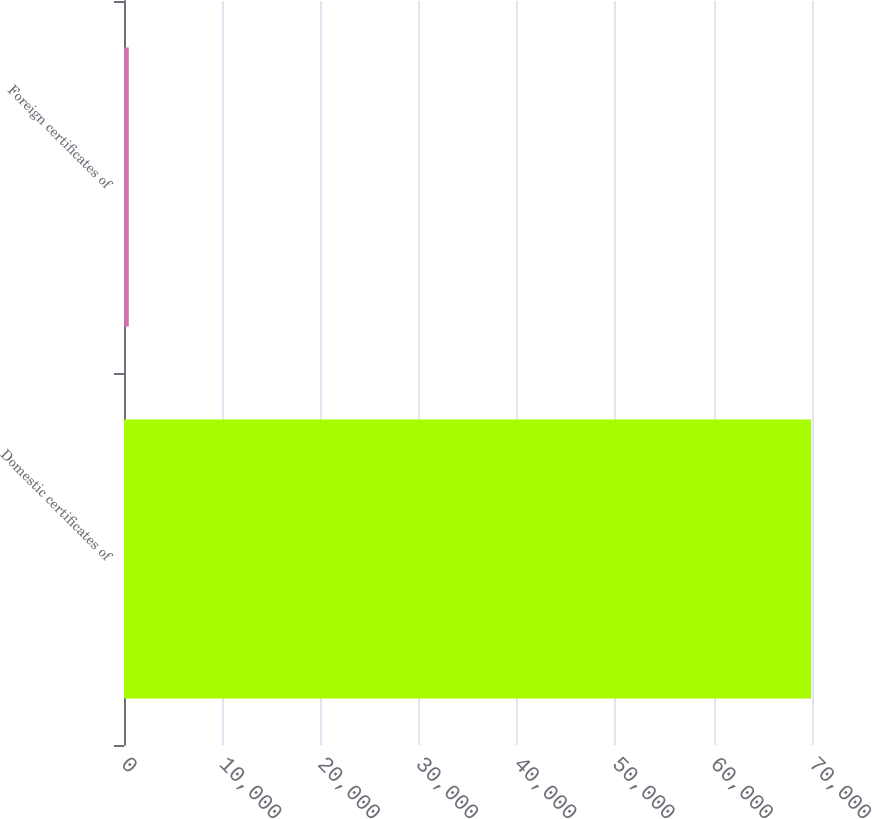<chart> <loc_0><loc_0><loc_500><loc_500><bar_chart><fcel>Domestic certificates of<fcel>Foreign certificates of<nl><fcel>69913<fcel>486<nl></chart> 